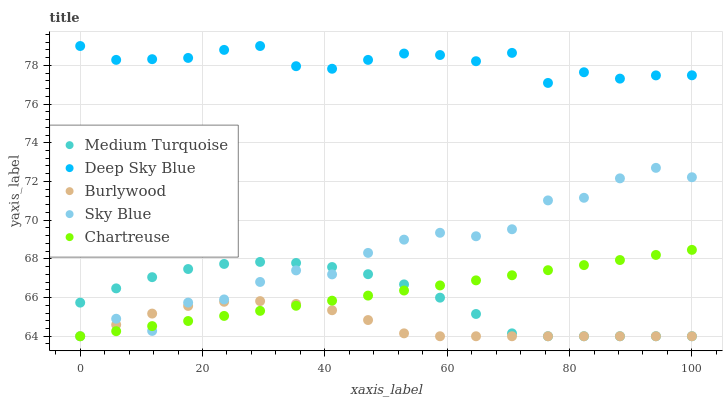Does Burlywood have the minimum area under the curve?
Answer yes or no. Yes. Does Deep Sky Blue have the maximum area under the curve?
Answer yes or no. Yes. Does Sky Blue have the minimum area under the curve?
Answer yes or no. No. Does Sky Blue have the maximum area under the curve?
Answer yes or no. No. Is Chartreuse the smoothest?
Answer yes or no. Yes. Is Sky Blue the roughest?
Answer yes or no. Yes. Is Sky Blue the smoothest?
Answer yes or no. No. Is Chartreuse the roughest?
Answer yes or no. No. Does Burlywood have the lowest value?
Answer yes or no. Yes. Does Deep Sky Blue have the lowest value?
Answer yes or no. No. Does Deep Sky Blue have the highest value?
Answer yes or no. Yes. Does Sky Blue have the highest value?
Answer yes or no. No. Is Medium Turquoise less than Deep Sky Blue?
Answer yes or no. Yes. Is Deep Sky Blue greater than Medium Turquoise?
Answer yes or no. Yes. Does Medium Turquoise intersect Chartreuse?
Answer yes or no. Yes. Is Medium Turquoise less than Chartreuse?
Answer yes or no. No. Is Medium Turquoise greater than Chartreuse?
Answer yes or no. No. Does Medium Turquoise intersect Deep Sky Blue?
Answer yes or no. No. 